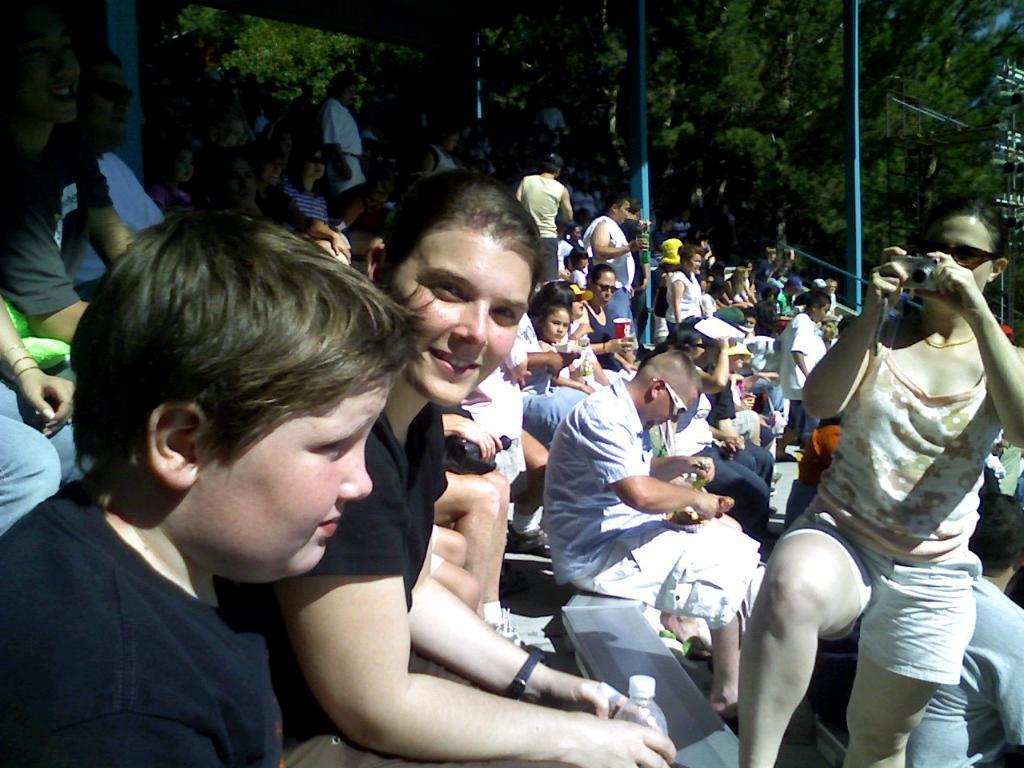Please provide a concise description of this image. In this image I can see a group of people sitting and few are holding bottles,cups and camera. Back I can see few poles and trees. 